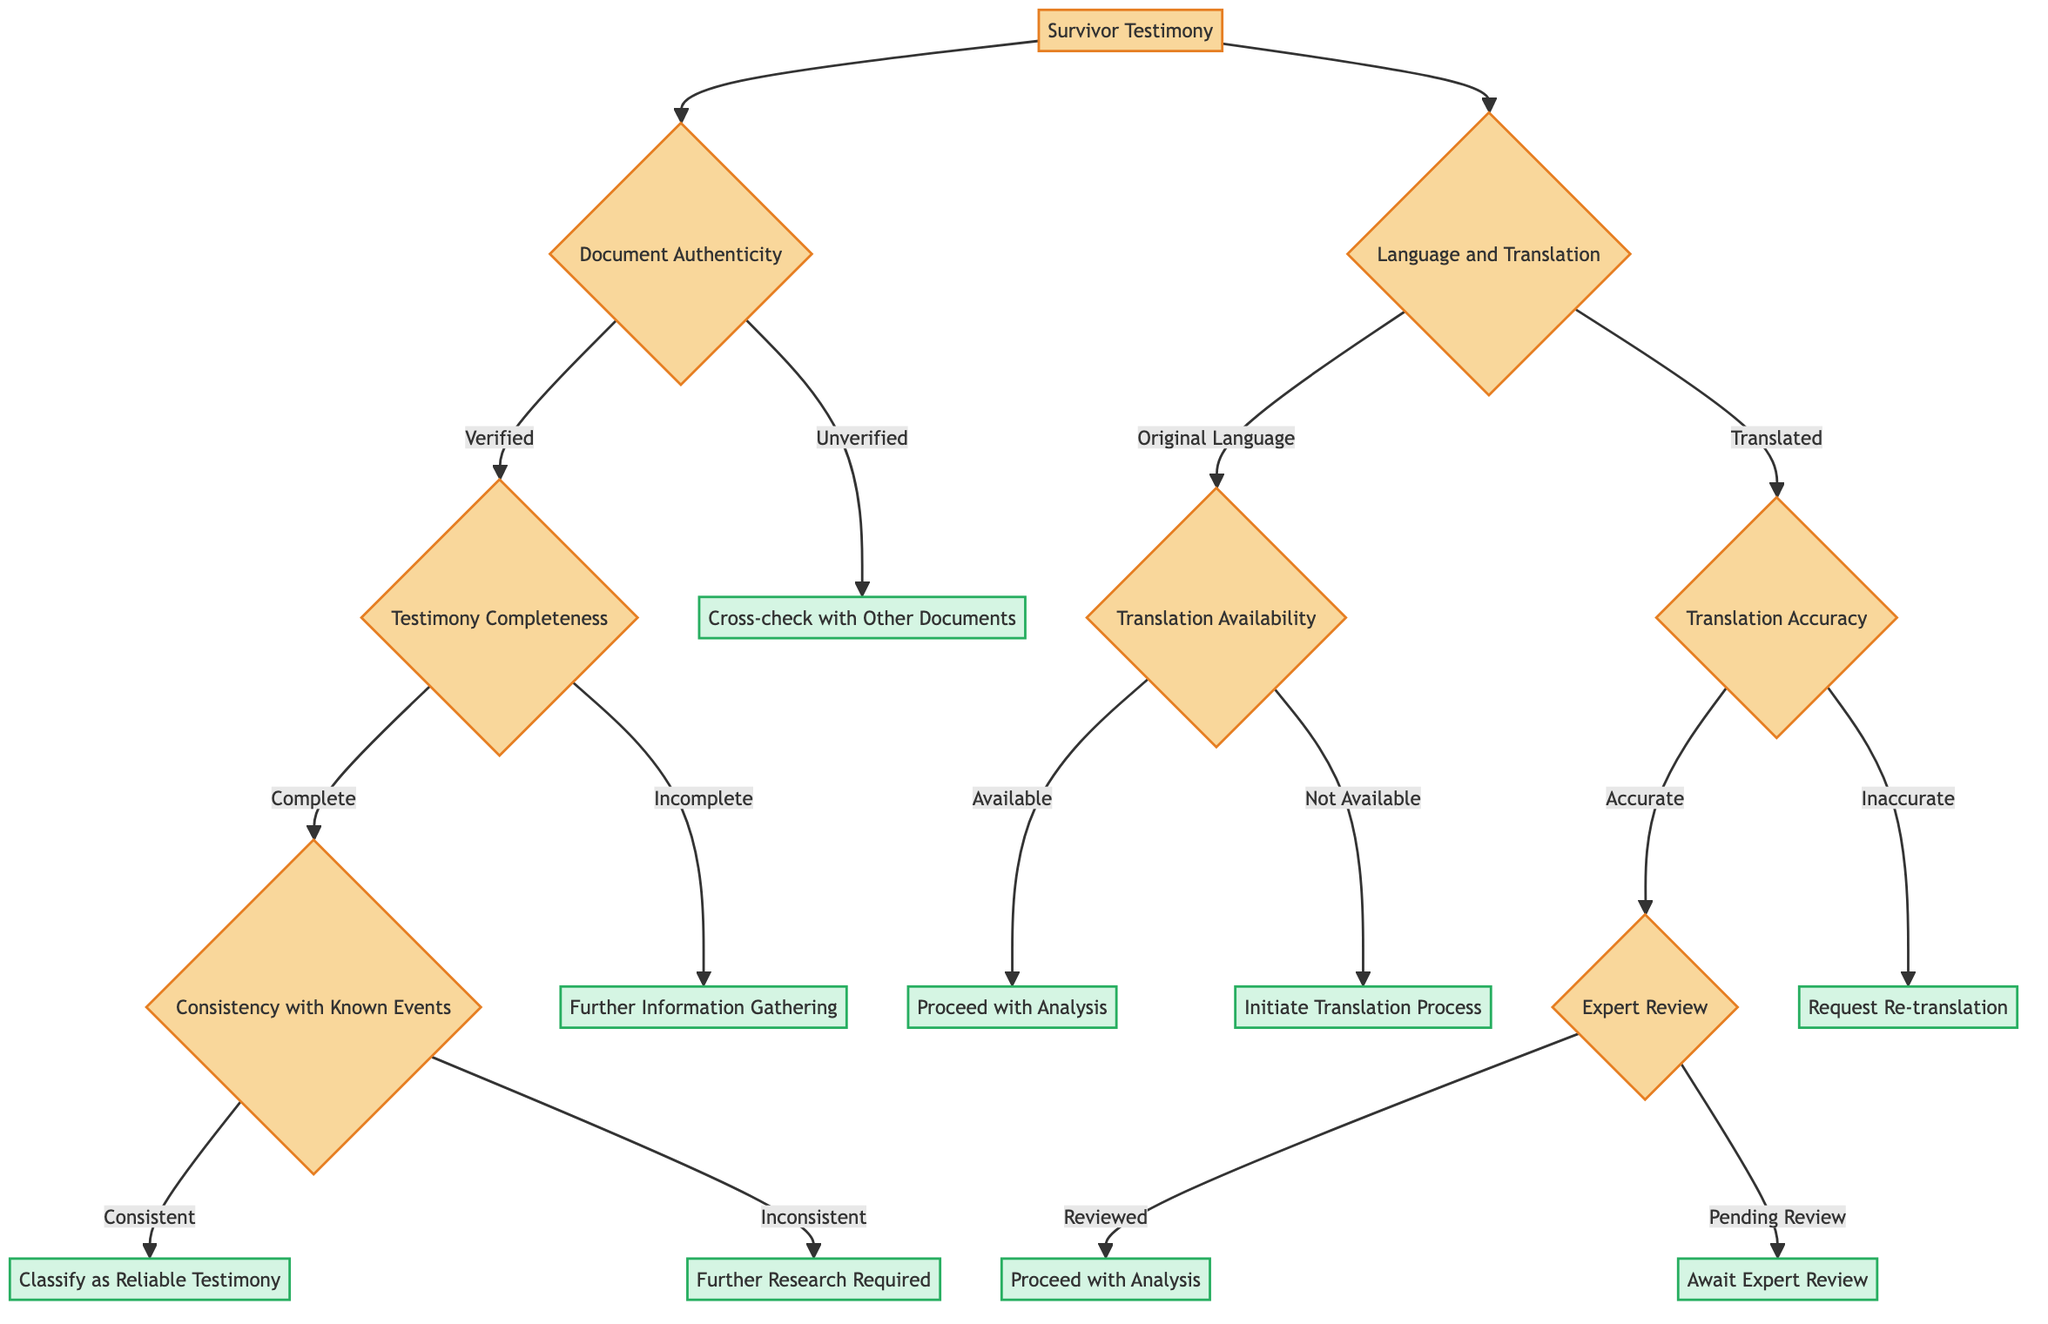What is the root node of the decision tree? The root node is the starting point of the decision tree, which is "Survivor Testimony."
Answer: Survivor Testimony How many main branches are there from the root node? The decision tree has two main branches stemming from the root node, which are "Document Authenticity" and "Language and Translation."
Answer: 2 What category follows "Verified" in the "Document Authenticity" branch? The next decision following "Verified" is "Testimony Completeness," which further branches into "Complete" and "Incomplete."
Answer: Testimony Completeness What decision is indicated for testimony that is classified as "Incomplete"? The decision for incomplete testimony is "Further Information Gathering," indicating that additional information is needed before classification.
Answer: Further Information Gathering What is the outcome if the testimony is categorized as "Inconsistent" with known events? The outcome for inconsistent testimony is "Further Research Required," indicating that more investigation is necessary to understand the discrepancies.
Answer: Further Research Required What do you do if the document is classified as "Unverified"? If the document is classified as unverified, the appropriate action is to "Cross-check with Other Documents."
Answer: Cross-check with Other Documents What is the next criterion to assess after "Translated" in the "Language and Translation" branch? After the testimony is categorized as "Translated," the next criterion to assess is "Translation Accuracy."
Answer: Translation Accuracy What happens if the translation is determined to be "Inaccurate"? If the translation is classified as inaccurate, the decision is to "Request Re-translation," meaning a new translation must be obtained.
Answer: Request Re-translation What is the final outcome if translation accuracy is evaluated as "Accurate" and reviewed? If the translation is accurate and has been reviewed by an expert, the final outcome is "Proceed with Analysis," leading to the further evaluation of the testimony.
Answer: Proceed with Analysis What is the action taken if the translation is "Not Available"? If the translation is not available, the action is to "Initiate Translation Process" to ensure the testimony can be analyzed.
Answer: Initiate Translation Process 